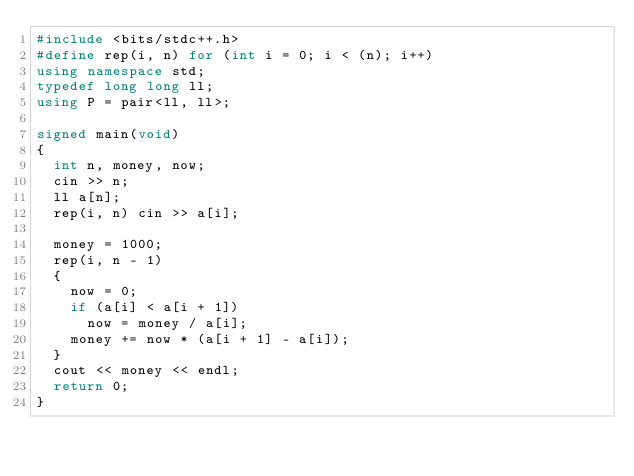<code> <loc_0><loc_0><loc_500><loc_500><_C++_>#include <bits/stdc++.h>
#define rep(i, n) for (int i = 0; i < (n); i++)
using namespace std;
typedef long long ll;
using P = pair<ll, ll>;

signed main(void)
{
	int n, money, now;
	cin >> n;
	ll a[n];
	rep(i, n) cin >> a[i];

	money = 1000;
	rep(i, n - 1)
	{
		now = 0;
		if (a[i] < a[i + 1]) 
			now = money / a[i];
		money += now * (a[i + 1] - a[i]);
	}
	cout << money << endl;
	return 0;
}
</code> 